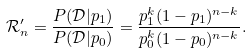<formula> <loc_0><loc_0><loc_500><loc_500>\mathcal { R } ^ { \prime } _ { n } = \frac { P ( \mathcal { D } | p _ { 1 } ) } { P ( \mathcal { D } | p _ { 0 } ) } = \frac { p _ { 1 } ^ { k } ( 1 - p _ { 1 } ) ^ { n - k } } { p _ { 0 } ^ { k } ( 1 - p _ { 0 } ) ^ { n - k } } .</formula> 